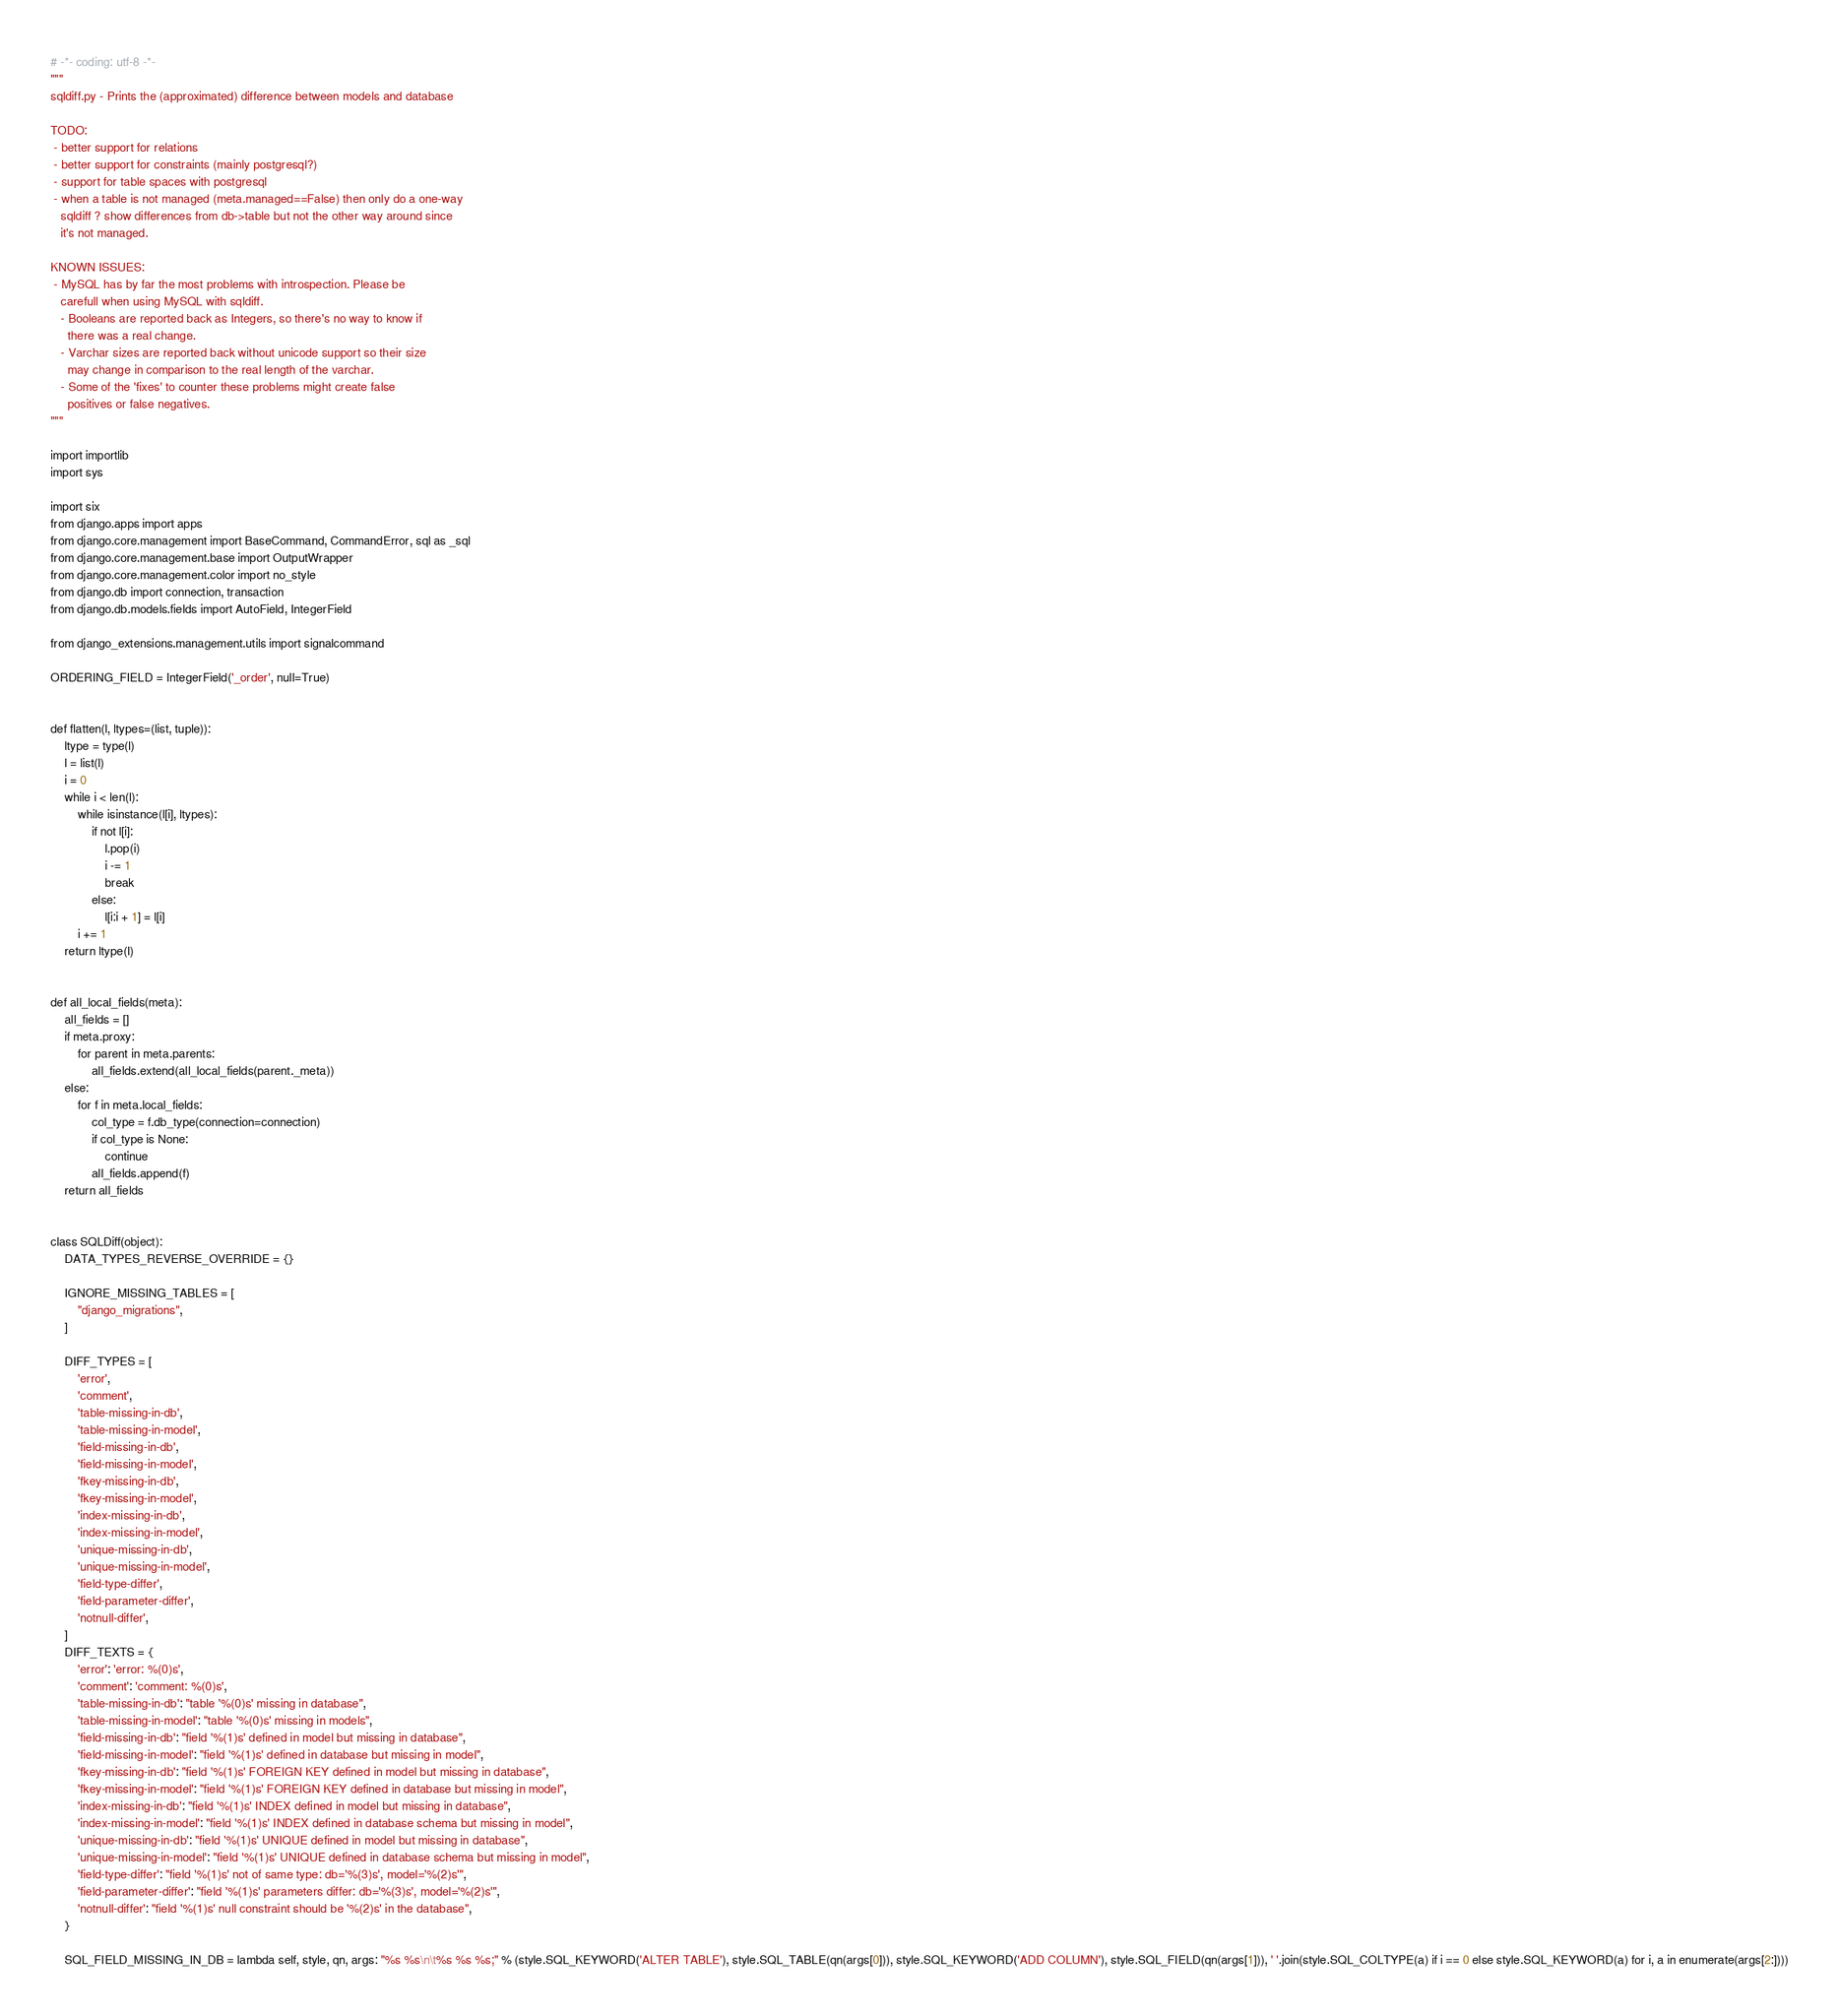Convert code to text. <code><loc_0><loc_0><loc_500><loc_500><_Python_># -*- coding: utf-8 -*-
"""
sqldiff.py - Prints the (approximated) difference between models and database

TODO:
 - better support for relations
 - better support for constraints (mainly postgresql?)
 - support for table spaces with postgresql
 - when a table is not managed (meta.managed==False) then only do a one-way
   sqldiff ? show differences from db->table but not the other way around since
   it's not managed.

KNOWN ISSUES:
 - MySQL has by far the most problems with introspection. Please be
   carefull when using MySQL with sqldiff.
   - Booleans are reported back as Integers, so there's no way to know if
     there was a real change.
   - Varchar sizes are reported back without unicode support so their size
     may change in comparison to the real length of the varchar.
   - Some of the 'fixes' to counter these problems might create false
     positives or false negatives.
"""

import importlib
import sys

import six
from django.apps import apps
from django.core.management import BaseCommand, CommandError, sql as _sql
from django.core.management.base import OutputWrapper
from django.core.management.color import no_style
from django.db import connection, transaction
from django.db.models.fields import AutoField, IntegerField

from django_extensions.management.utils import signalcommand

ORDERING_FIELD = IntegerField('_order', null=True)


def flatten(l, ltypes=(list, tuple)):
    ltype = type(l)
    l = list(l)
    i = 0
    while i < len(l):
        while isinstance(l[i], ltypes):
            if not l[i]:
                l.pop(i)
                i -= 1
                break
            else:
                l[i:i + 1] = l[i]
        i += 1
    return ltype(l)


def all_local_fields(meta):
    all_fields = []
    if meta.proxy:
        for parent in meta.parents:
            all_fields.extend(all_local_fields(parent._meta))
    else:
        for f in meta.local_fields:
            col_type = f.db_type(connection=connection)
            if col_type is None:
                continue
            all_fields.append(f)
    return all_fields


class SQLDiff(object):
    DATA_TYPES_REVERSE_OVERRIDE = {}

    IGNORE_MISSING_TABLES = [
        "django_migrations",
    ]

    DIFF_TYPES = [
        'error',
        'comment',
        'table-missing-in-db',
        'table-missing-in-model',
        'field-missing-in-db',
        'field-missing-in-model',
        'fkey-missing-in-db',
        'fkey-missing-in-model',
        'index-missing-in-db',
        'index-missing-in-model',
        'unique-missing-in-db',
        'unique-missing-in-model',
        'field-type-differ',
        'field-parameter-differ',
        'notnull-differ',
    ]
    DIFF_TEXTS = {
        'error': 'error: %(0)s',
        'comment': 'comment: %(0)s',
        'table-missing-in-db': "table '%(0)s' missing in database",
        'table-missing-in-model': "table '%(0)s' missing in models",
        'field-missing-in-db': "field '%(1)s' defined in model but missing in database",
        'field-missing-in-model': "field '%(1)s' defined in database but missing in model",
        'fkey-missing-in-db': "field '%(1)s' FOREIGN KEY defined in model but missing in database",
        'fkey-missing-in-model': "field '%(1)s' FOREIGN KEY defined in database but missing in model",
        'index-missing-in-db': "field '%(1)s' INDEX defined in model but missing in database",
        'index-missing-in-model': "field '%(1)s' INDEX defined in database schema but missing in model",
        'unique-missing-in-db': "field '%(1)s' UNIQUE defined in model but missing in database",
        'unique-missing-in-model': "field '%(1)s' UNIQUE defined in database schema but missing in model",
        'field-type-differ': "field '%(1)s' not of same type: db='%(3)s', model='%(2)s'",
        'field-parameter-differ': "field '%(1)s' parameters differ: db='%(3)s', model='%(2)s'",
        'notnull-differ': "field '%(1)s' null constraint should be '%(2)s' in the database",
    }

    SQL_FIELD_MISSING_IN_DB = lambda self, style, qn, args: "%s %s\n\t%s %s %s;" % (style.SQL_KEYWORD('ALTER TABLE'), style.SQL_TABLE(qn(args[0])), style.SQL_KEYWORD('ADD COLUMN'), style.SQL_FIELD(qn(args[1])), ' '.join(style.SQL_COLTYPE(a) if i == 0 else style.SQL_KEYWORD(a) for i, a in enumerate(args[2:])))</code> 